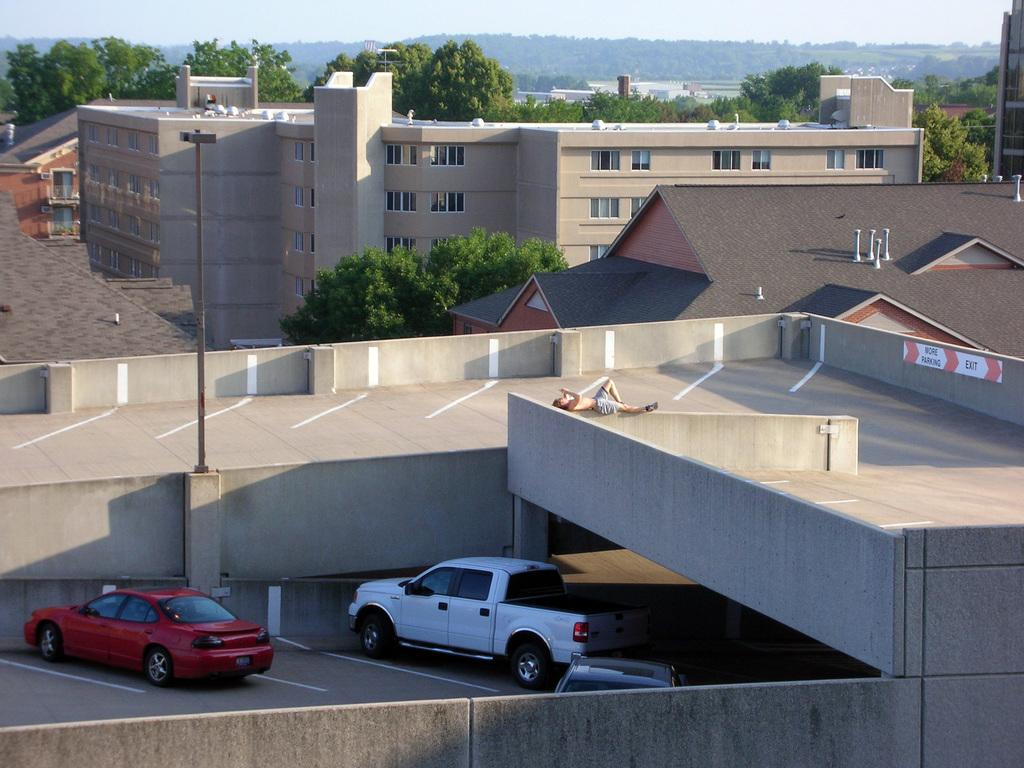What can be seen in the image related to transportation? There are vehicles parked in the image. What is the person in the image doing? A person is lying on a wall in the image. What object can be seen in the image that is made of metal? There is an iron pole in the image. What type of structures can be seen in the background of the image? There are buildings in the background of various sizes in the background of the image. What type of natural elements can be seen in the background of the image? Trees, mountains, and the sky are visible in the background of the image. What type of locket is the person wearing around their neck in the image? There is no locket visible around the person's neck in the image. What type of milk is being served in the image? There is no milk present in the image. 